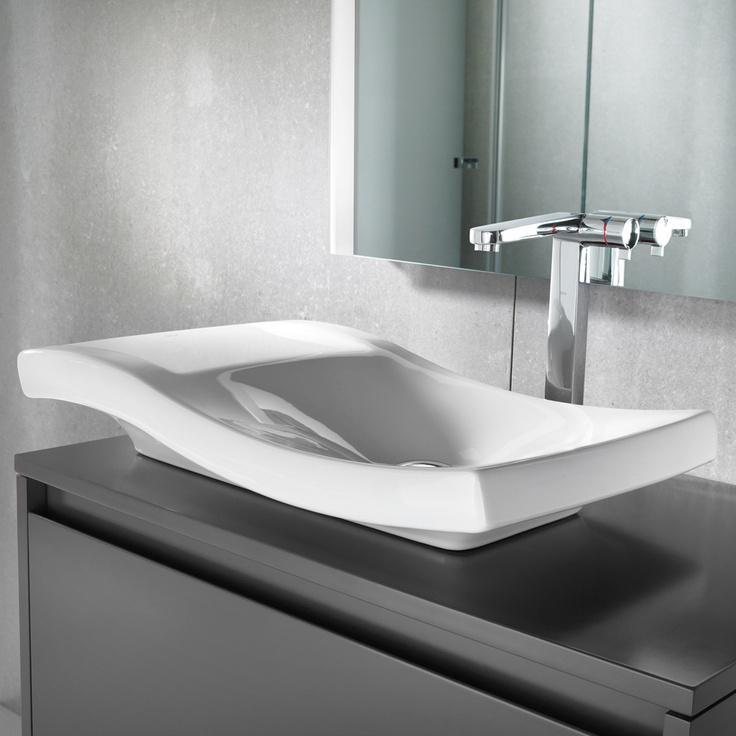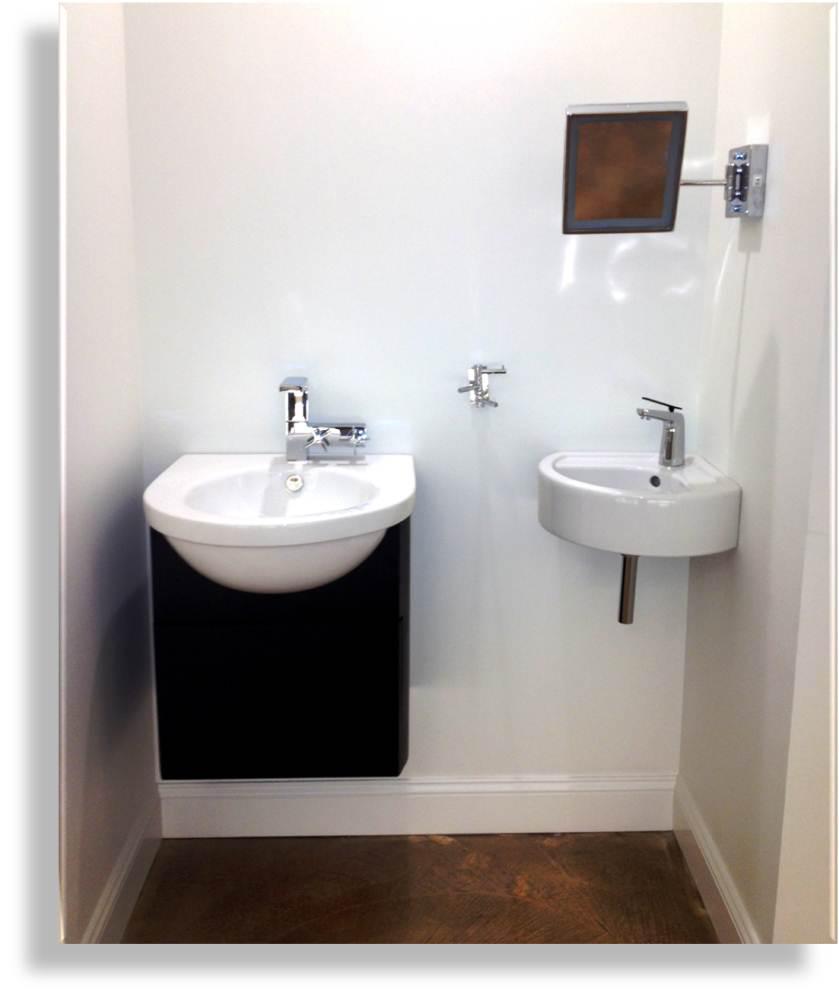The first image is the image on the left, the second image is the image on the right. For the images shown, is this caption "An image shows a white rectangular sink with two separate faucets." true? Answer yes or no. No. 